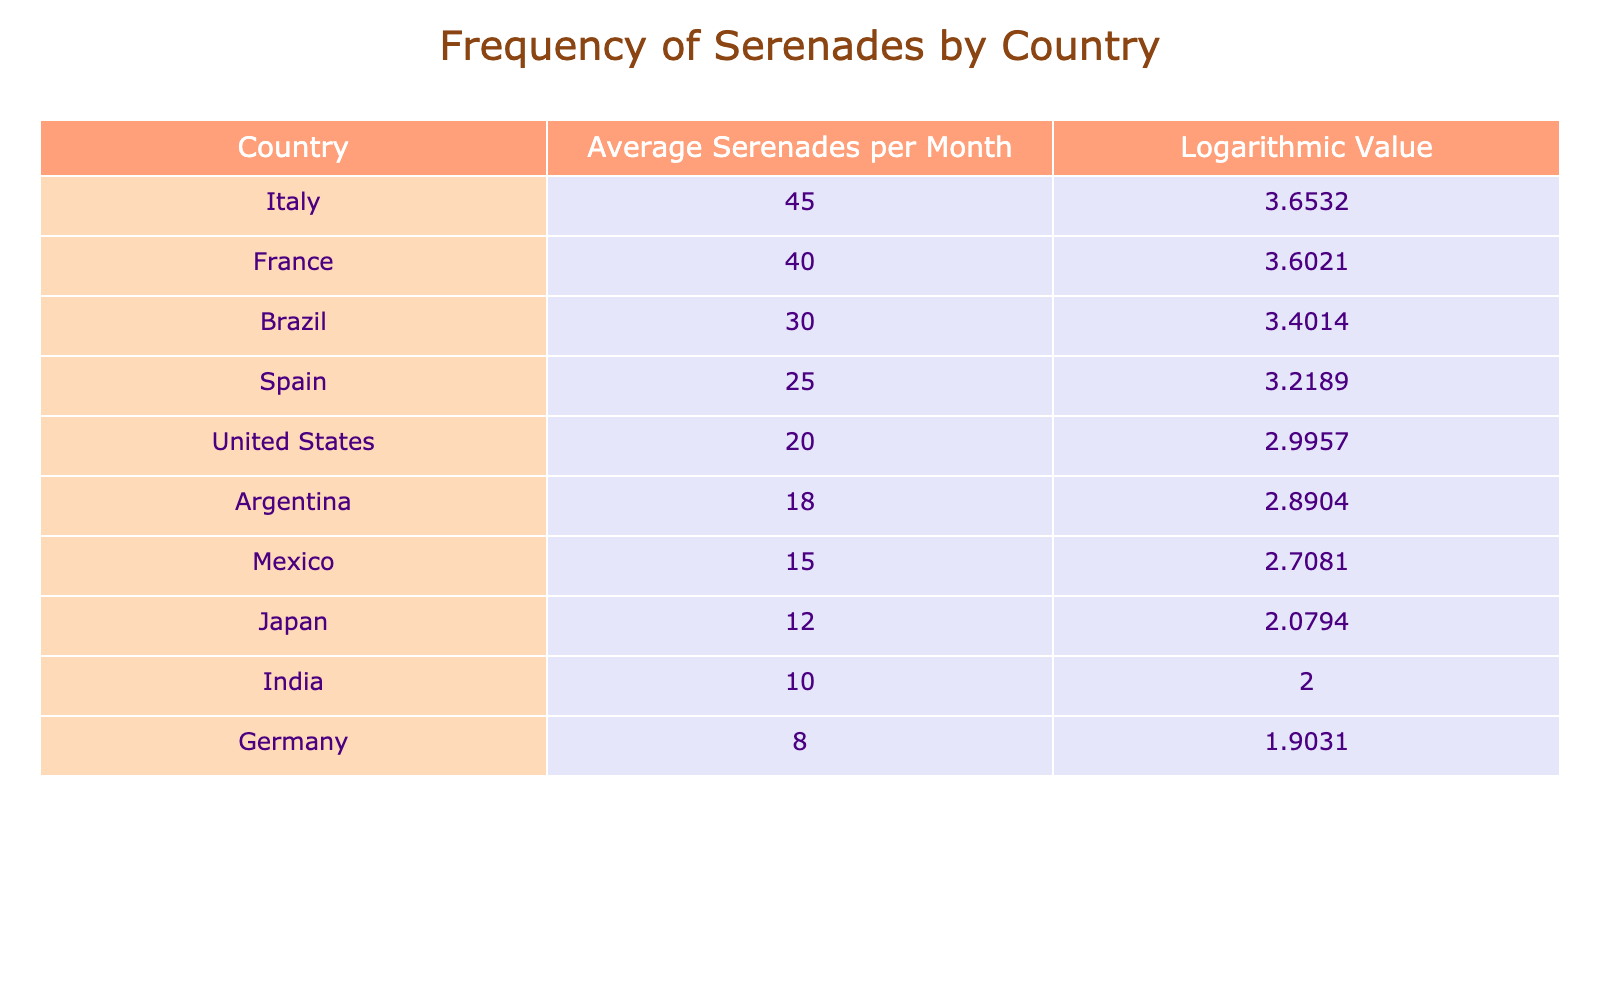What is the average number of serenades performed in Italy? The table shows that the average number of serenades performed in Italy is listed as 45.
Answer: 45 Which country has the lowest average number of serenades per month? The table shows that India has the lowest average number of serenades at 10.
Answer: India How many more serenades does Italy perform compared to Germany? To find the difference, subtract Germany's average (8) from Italy's average (45): 45 - 8 = 37.
Answer: 37 Is it true that France performs more serenades on average than the United States? The table indicates that France has an average of 40 serenades, while the United States has 20. Thus, the statement is true.
Answer: Yes What is the sum of the average number of serenades performed by Brazil and Spain? Adding Brazil's average (30) and Spain's average (25): 30 + 25 = 55.
Answer: 55 Which two countries have an average number of serenades that are closest together? Looking at the average numbers, Argentina (18) and Mexico (15) have the closest averages, differing by 3.
Answer: Argentina and Mexico What is the difference in logarithmic values between the country with the highest and lowest averages? The logarithmic value for Italy (highest average) is 3.6532 and for India (lowest average) is 2.0000. The difference is 3.6532 - 2.0000 = 1.6532.
Answer: 1.6532 How many countries have an average of more than 20 serenades per month? Referring to the table, the countries with more than 20 serenades are Italy, France, Brazil, and Spain (4 countries).
Answer: 4 Which country performs more than 10 but less than 20 serenades on average? The table shows that Argentina (18) and Mexico (15) perform between 10 and 20 serenades on average.
Answer: Argentina and Mexico 